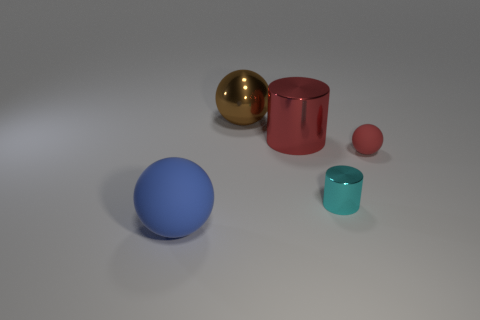Add 3 big matte objects. How many objects exist? 8 Subtract all cylinders. How many objects are left? 3 Add 2 big brown things. How many big brown things are left? 3 Add 3 big cylinders. How many big cylinders exist? 4 Subtract 0 yellow balls. How many objects are left? 5 Subtract all tiny yellow blocks. Subtract all large red cylinders. How many objects are left? 4 